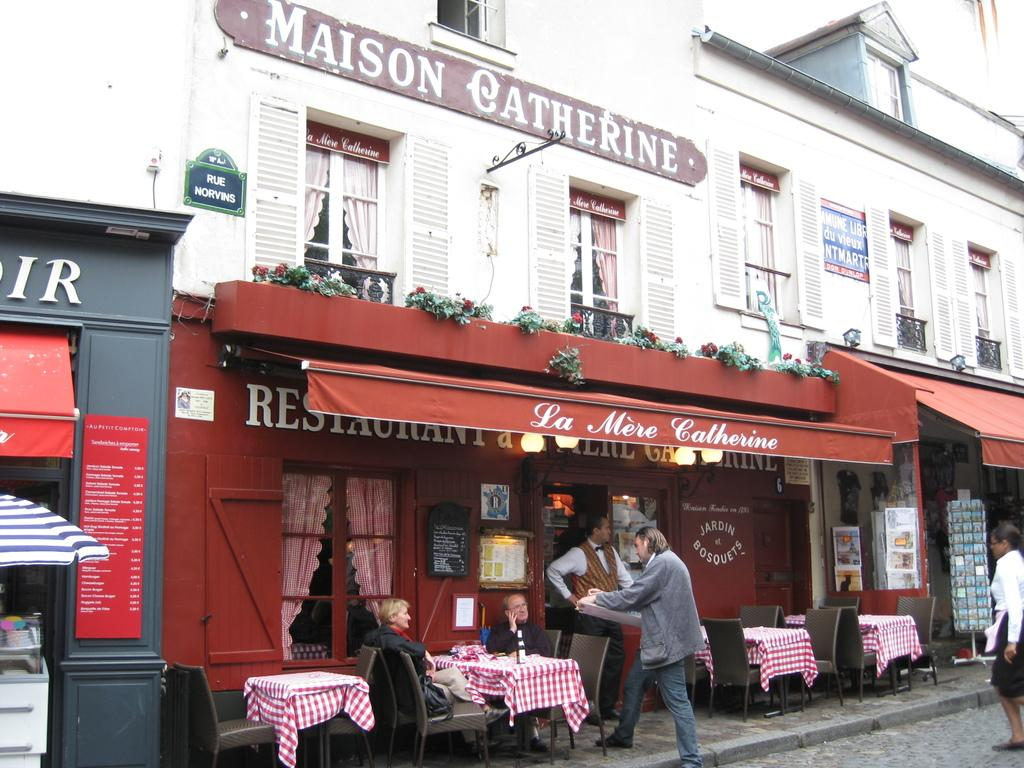What type of structure can be seen in the image? There is a building in the image. What piece of furniture is present in the image? There is a table and a chair in the image. What object can be seen on the table? There is a bottle in the image. What type of signage is visible in the image? There is a hoarding and a name board in the image. Are there any people in the image? Yes, there are persons in the image. What additional item can be seen in the image? There is an umbrella in the image. What type of vegetation is present in the image? There are plants in the image. What is the aftermath of the tree falling in the image? There is no tree falling in the image, so there is no aftermath to describe. How does the stomach of the person in the image feel? There is no information about the person's stomach in the image, so it cannot be determined how they feel. 